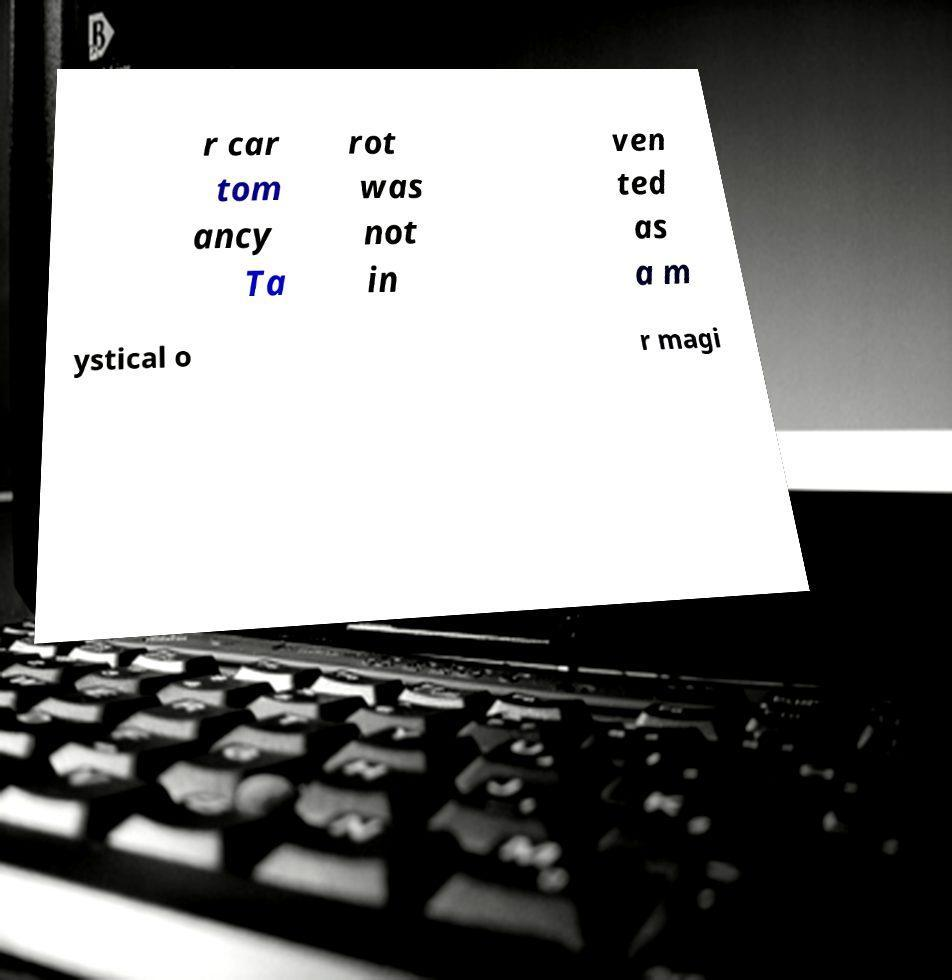I need the written content from this picture converted into text. Can you do that? r car tom ancy Ta rot was not in ven ted as a m ystical o r magi 